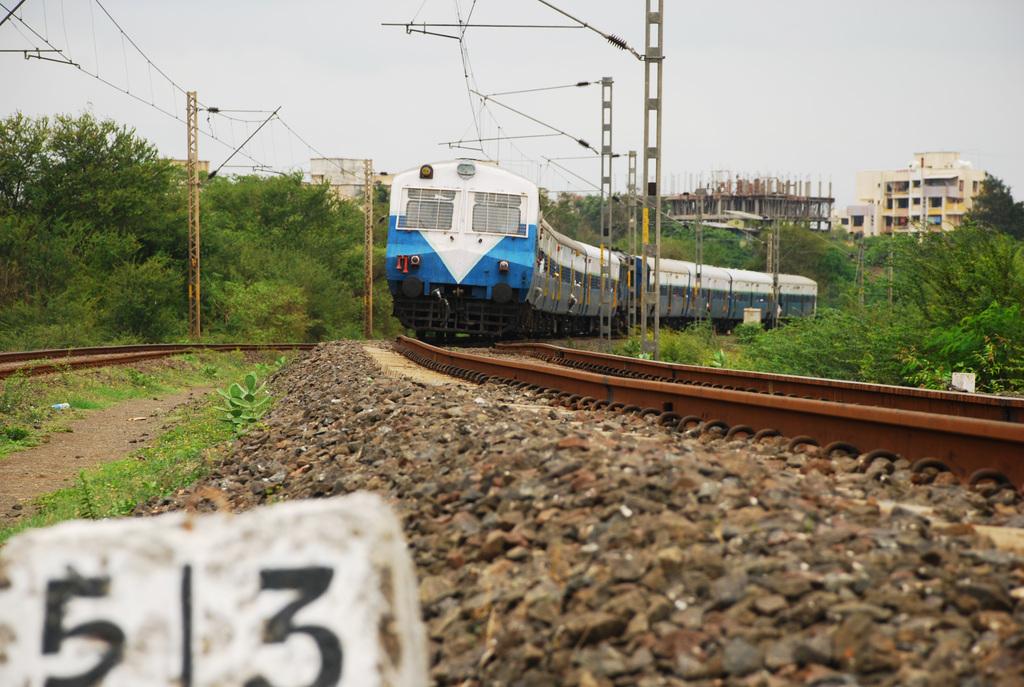What number is shown?
Make the answer very short. 53. 